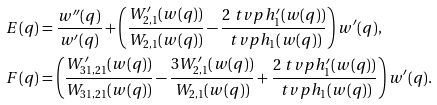<formula> <loc_0><loc_0><loc_500><loc_500>E ( q ) & = \frac { w ^ { \prime \prime } ( q ) } { w ^ { \prime } ( q ) } + \left ( \frac { W ^ { \prime } _ { 2 , 1 } ( w ( q ) ) } { W _ { 2 , 1 } ( w ( q ) ) } - \frac { 2 \ t v p h ^ { \prime } _ { 1 } ( w ( q ) ) } { \ t v p h _ { 1 } ( w ( q ) ) } \right ) w ^ { \prime } ( q ) , \\ F ( q ) & = \left ( \frac { W ^ { \prime } _ { 3 1 , 2 1 } ( w ( q ) ) } { W _ { 3 1 , 2 1 } ( w ( q ) ) } - \frac { 3 W ^ { \prime } _ { 2 , 1 } ( w ( q ) ) } { W _ { 2 , 1 } ( w ( q ) ) } + \frac { 2 \ t v p h ^ { \prime } _ { 1 } ( w ( q ) ) } { \ t v p h _ { 1 } ( w ( q ) ) } \right ) w ^ { \prime } ( q ) .</formula> 